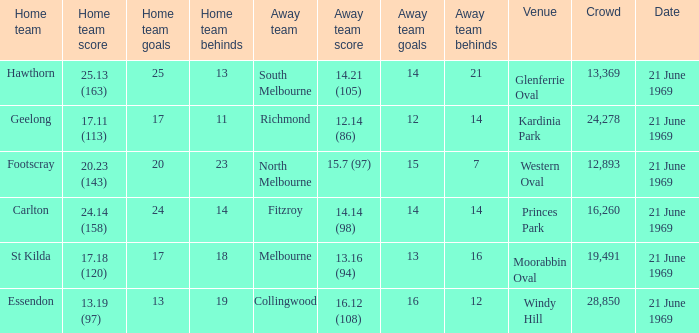When did an away team score 15.7 (97)? 21 June 1969. 